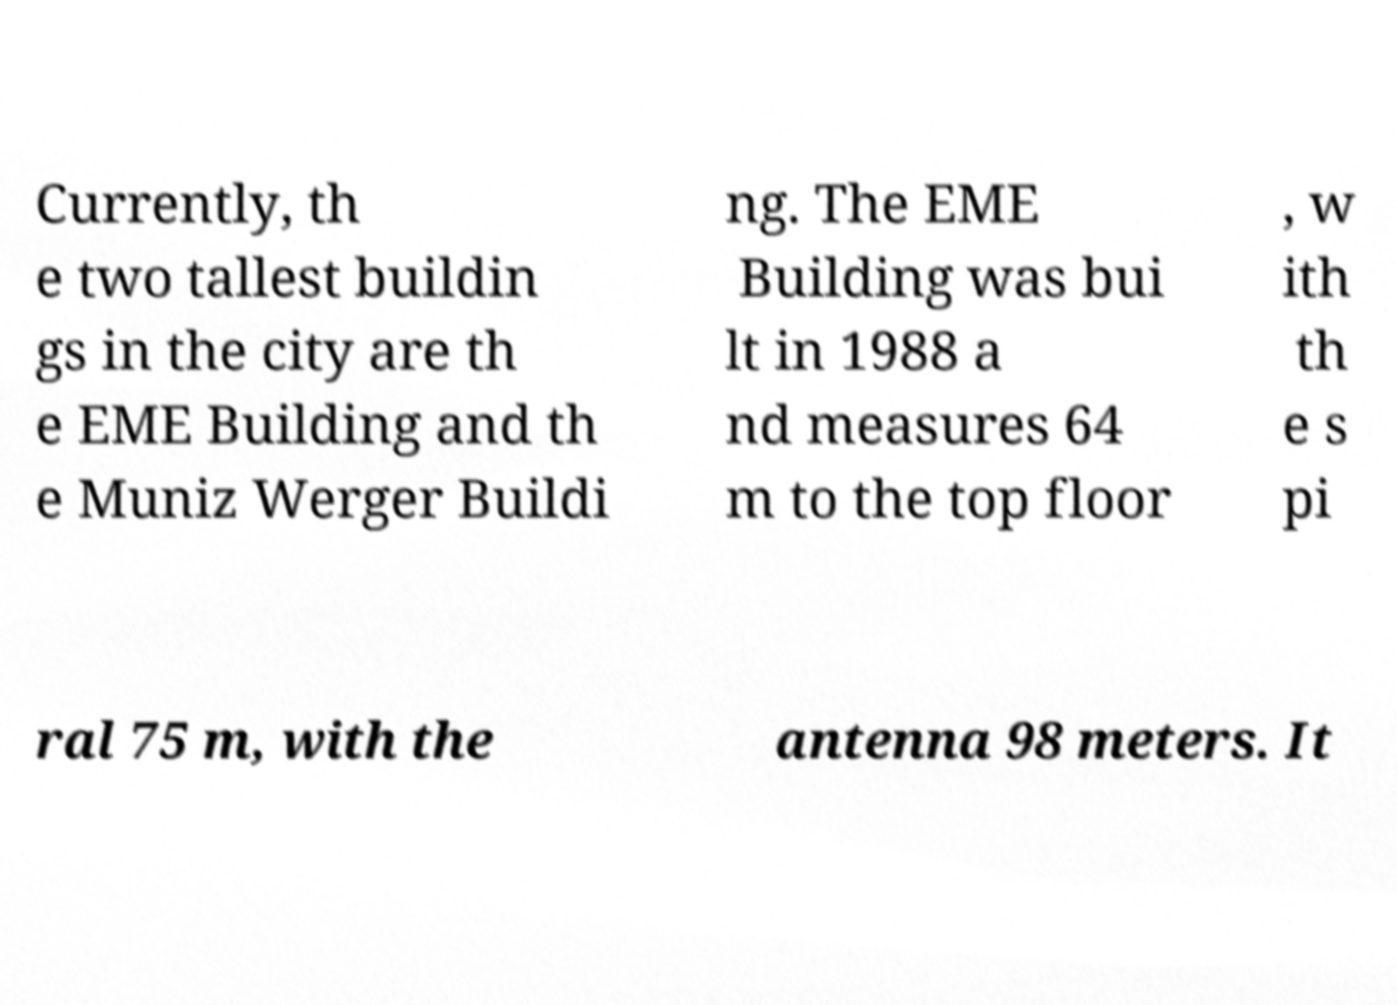Can you accurately transcribe the text from the provided image for me? Currently, th e two tallest buildin gs in the city are th e EME Building and th e Muniz Werger Buildi ng. The EME Building was bui lt in 1988 a nd measures 64 m to the top floor , w ith th e s pi ral 75 m, with the antenna 98 meters. It 